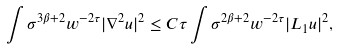<formula> <loc_0><loc_0><loc_500><loc_500>\int \sigma ^ { 3 \beta + 2 } w ^ { - 2 \tau } | \nabla ^ { 2 } u | ^ { 2 } \leq C \tau \int \sigma ^ { 2 \beta + 2 } w ^ { - 2 \tau } | L _ { 1 } u | ^ { 2 } ,</formula> 